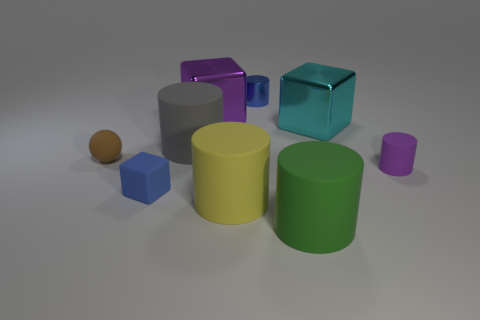Does the metal block on the right side of the big yellow cylinder have the same size as the metallic block behind the big cyan object?
Offer a terse response. Yes. What is the shape of the green matte thing?
Give a very brief answer. Cylinder. What size is the cube that is the same color as the small matte cylinder?
Your answer should be compact. Large. The block that is the same material as the small purple cylinder is what color?
Keep it short and to the point. Blue. Are the blue block and the tiny cylinder that is in front of the small blue metal cylinder made of the same material?
Your answer should be compact. Yes. The small cube is what color?
Offer a very short reply. Blue. There is another block that is the same material as the large purple block; what is its size?
Make the answer very short. Large. There is a purple thing that is in front of the large object right of the green thing; what number of things are in front of it?
Provide a succinct answer. 3. Do the small rubber cylinder and the large cube to the left of the cyan metallic block have the same color?
Offer a very short reply. Yes. The rubber thing that is the same color as the metal cylinder is what shape?
Provide a short and direct response. Cube. 